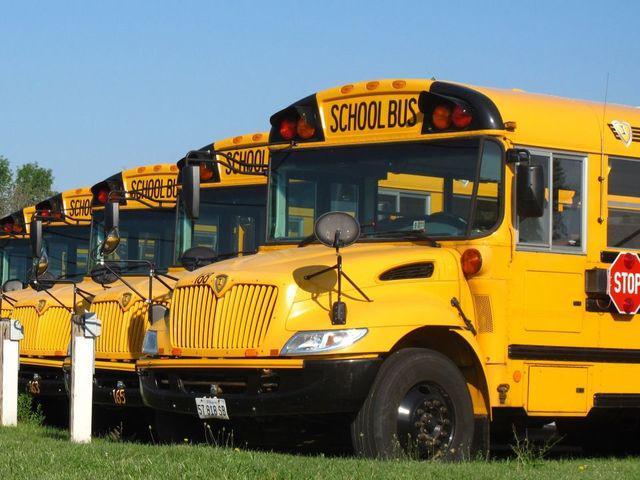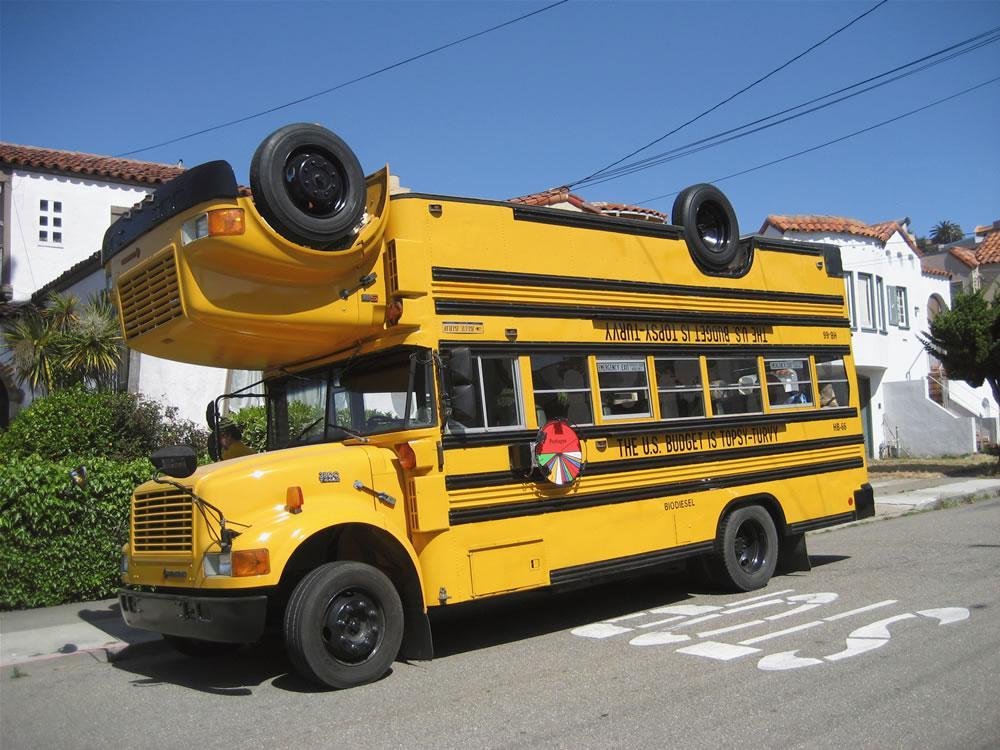The first image is the image on the left, the second image is the image on the right. Considering the images on both sides, is "In the image to the left, there are less than six buses." valid? Answer yes or no. Yes. The first image is the image on the left, the second image is the image on the right. Analyze the images presented: Is the assertion "At least one image shows the rear-facing tail end of a parked yellow bus, and no image shows a non-flat bus front." valid? Answer yes or no. No. 